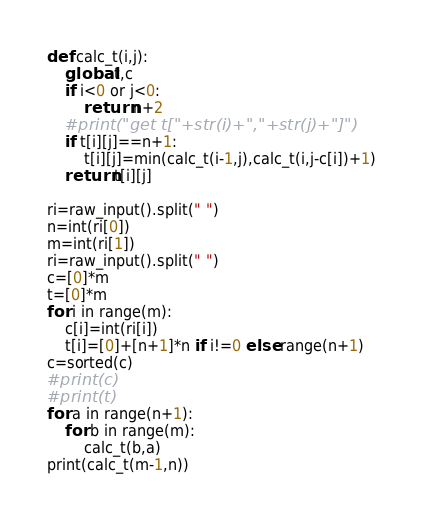<code> <loc_0><loc_0><loc_500><loc_500><_Python_>def calc_t(i,j):
    global t,c
    if i<0 or j<0:
        return n+2
    #print("get t["+str(i)+","+str(j)+"]")
    if t[i][j]==n+1:
        t[i][j]=min(calc_t(i-1,j),calc_t(i,j-c[i])+1)
    return t[i][j]

ri=raw_input().split(" ")
n=int(ri[0])
m=int(ri[1])
ri=raw_input().split(" ")
c=[0]*m
t=[0]*m
for i in range(m):
    c[i]=int(ri[i])
    t[i]=[0]+[n+1]*n if i!=0 else range(n+1)
c=sorted(c)
#print(c)
#print(t)
for a in range(n+1):
    for b in range(m):
        calc_t(b,a)
print(calc_t(m-1,n))</code> 